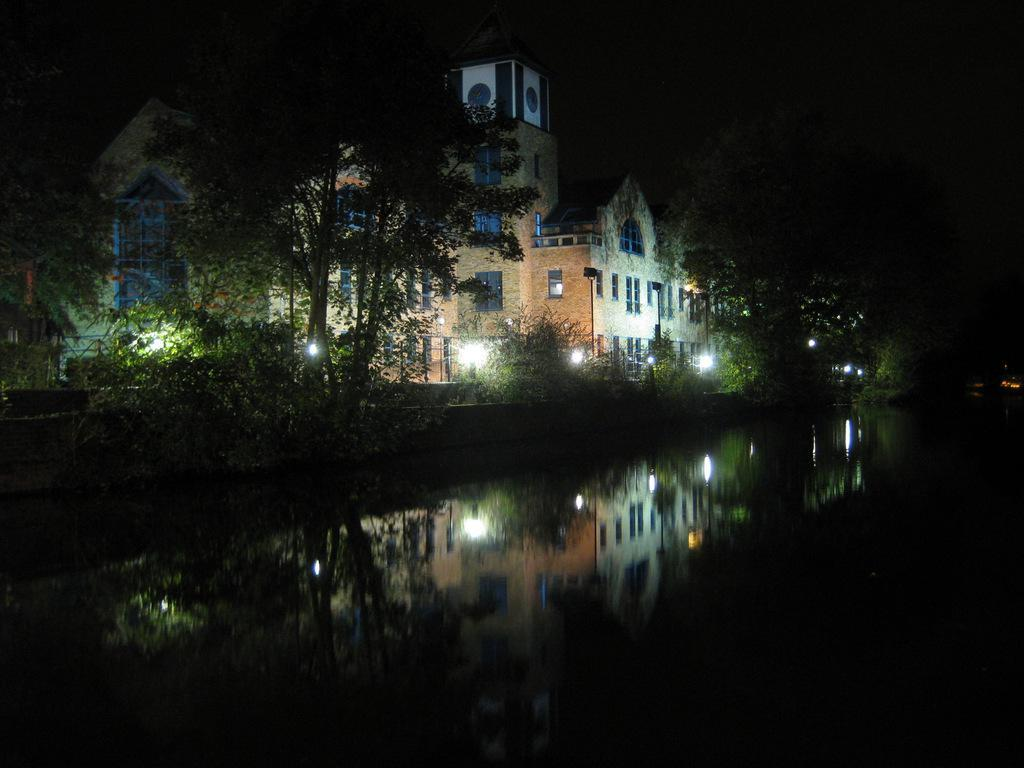What is the primary element visible in the image? There is water in the image. What type of barrier can be seen in the image? There is a fence in the image. What type of vegetation is present in the image? There is grass, plants, and trees in the image. What type of structures are visible in the image? There are buildings in the image. What part of the natural environment is visible in the image? The sky is visible in the image. Can you determine the time of day the image was taken? The image may have been taken during the night, as there is no visible sunlight. What type of straw is being used to build the sail in the image? There is no straw or sail present in the image. What type of bird can be seen perched on the fence in the image? There is no bird visible in the image, including a robin. 